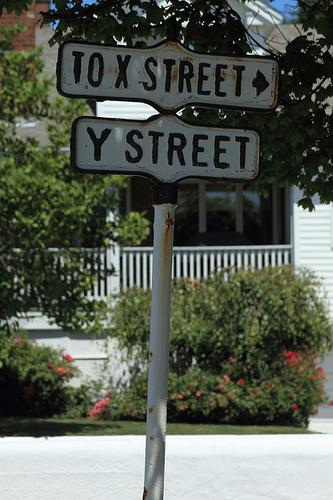Describe the colors, shapes, and positions of the most noticeable objects in the image. There are white and black street signs in square shapes located at the top left, a white porch railing in a rectangular shape, and round red flowers on a bush towards the bottom right. Write a summary of the overall content of the photograph. The photograph shows a neighborhood with a white house, a white porch railing, a green lawn, street signs, and colorful red and pink flower bushes. List five elements you can observe in the image. Street signs, white porch railing, red flowers on a bush, a paved street, and a white window on a house. List three prominent elements of the image and their colors. White and black street signs, red flowers on a bush, and a white porch railing. Write a brief scene of the image using descriptive language. A quaint scene unfolds as picturesque street signs jut from their metal post, nestled among vibrant flowers and a lovely white porch railing in a charming neighborhood. Provide a general description of the photograph's atmosphere. The image has a peaceful atmosphere, showing a quiet street with a white house, porch railing, green lawn, and colorful flowers near street signs. Describe the setting of the image as if you were there. I'm standing on a paved street, near a white house with a white porch railing and a small patch of green lawn. There are colorful flowers on bushes, and I can see a black and white street sign on a sign post. Mention the primary focus of the image and any surrounding objects. The primary focus is on the white and black street signs, with the sign post, porch railing, and flowering bushes nearby. Mention the most eye-catching aspect of the image and any accompanying details. The black-and-white street sign stands out, supported by a white metal sign post surrounded by red and pink flowers on a bush. Explain the components of the image in a concise manner. The image shows street signs on a sign post, a house with a white porch railing and window, red and pink flowers on a bush, and a nearby lawn and street. 